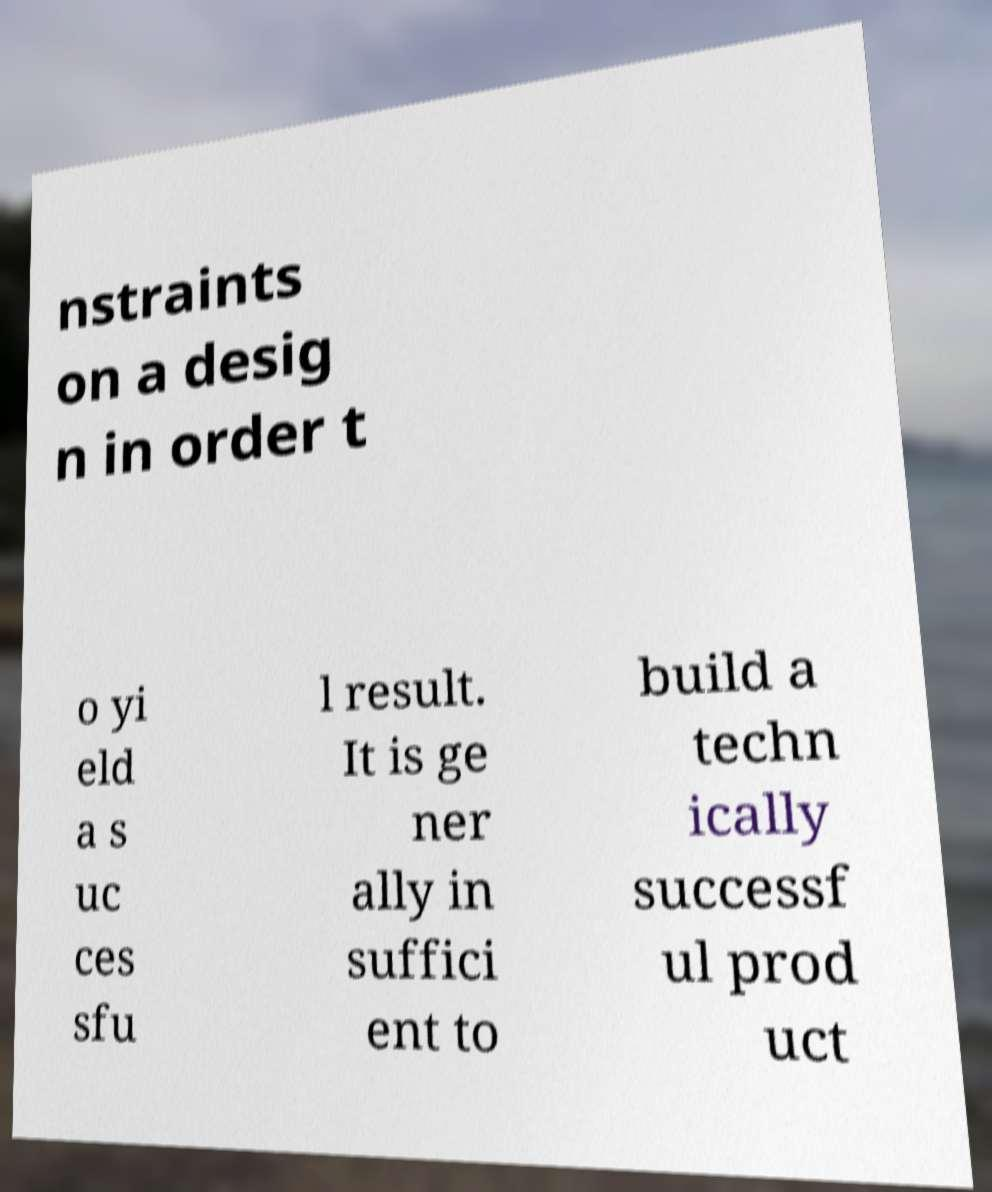Please identify and transcribe the text found in this image. nstraints on a desig n in order t o yi eld a s uc ces sfu l result. It is ge ner ally in suffici ent to build a techn ically successf ul prod uct 